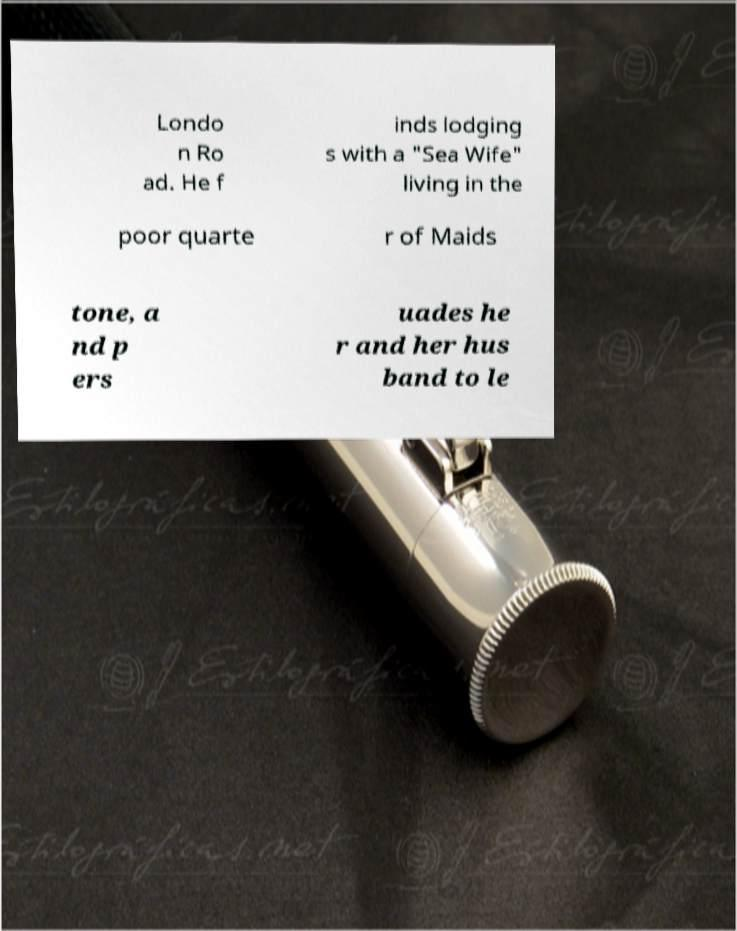Can you read and provide the text displayed in the image?This photo seems to have some interesting text. Can you extract and type it out for me? Londo n Ro ad. He f inds lodging s with a "Sea Wife" living in the poor quarte r of Maids tone, a nd p ers uades he r and her hus band to le 